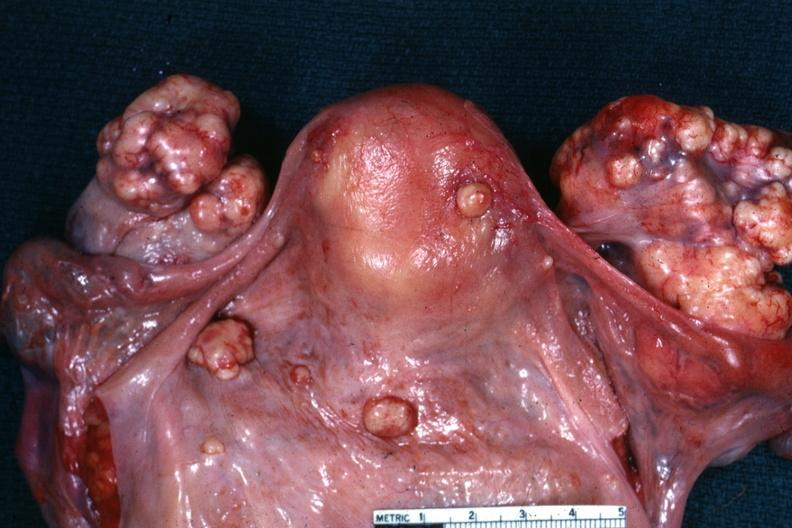what was peritoneal surface of uterus and douglas pouch outstanding photo primary in this is true bilateral krukenberg?
Answer the question using a single word or phrase. In the stomach 